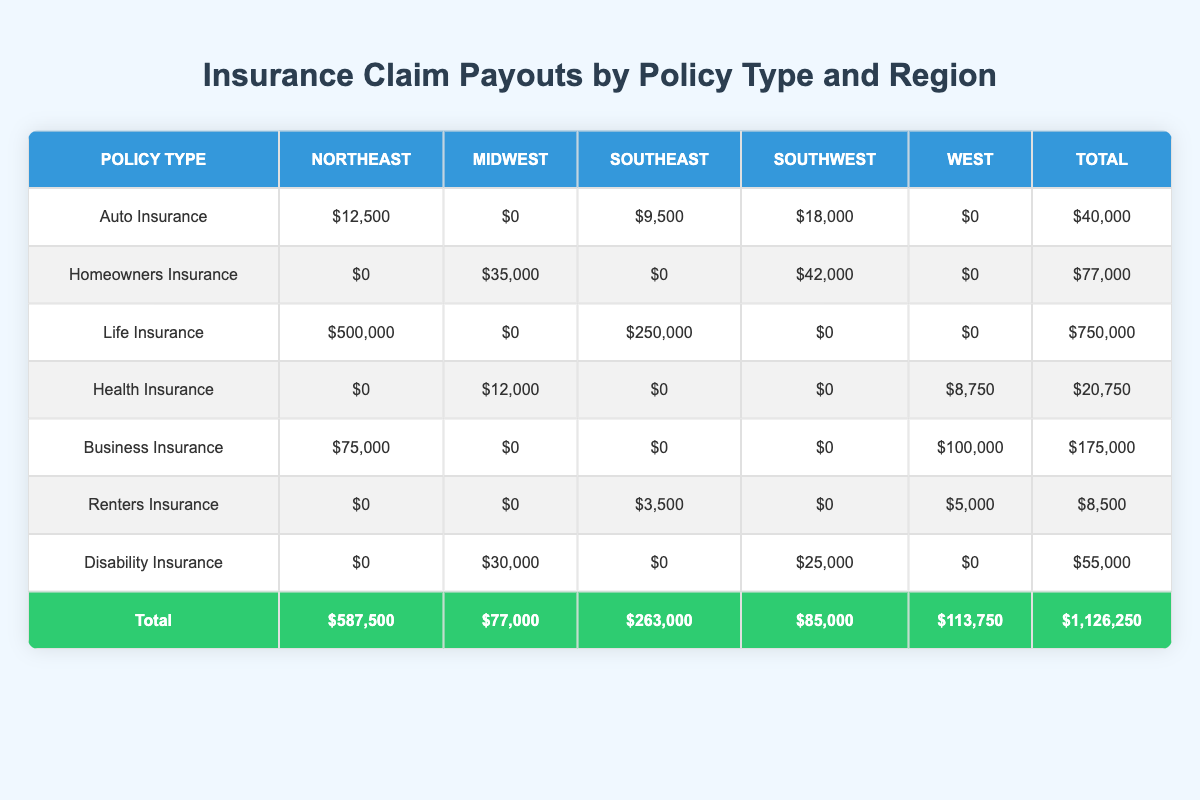What is the total claim amount for Life Insurance in the Northeast region? The table shows a claim amount of $500,000 for Life Insurance in the Northeast region. This is the only entry for Life Insurance in that region.
Answer: 500000 Which policy type received the highest total claim amount across all regions? By examining the total column, Life Insurance has the highest total claim amount of $750,000. This is greater than any other policy type totals listed.
Answer: Life Insurance What is the total claim amount for Homeowners Insurance in the Southwest region? The table indicates a claim amount of $42,000 for Homeowners Insurance under the Southwest region. This is the only entry listed for that policy type and region.
Answer: 42000 Is the total claim amount for Disability Insurance equal to the total for Renters Insurance? The total claim amount for Disability Insurance is $55,000 and for Renters Insurance, it is $8,500. Since $55,000 is not equal to $8,500, the statement is false.
Answer: No What is the difference in total payout between Auto Insurance and Business Insurance? The total payout for Auto Insurance is $40,000 and for Business Insurance, it is $175,000. The difference is calculated as $175,000 - $40,000 = $135,000.
Answer: 135000 Which region has the highest total claim payouts overall? The total column shows that the Northeast region has a total claim payout of $587,500, which is more than any other region's total (Midwest: $77,000; Southeast: $263,000; Southwest: $85,000; West: $113,750).
Answer: Northeast How much did Health Insurance claim in the West region? According to the table, the claim amount for Health Insurance in the West region is $8,750, which is correctly reflected under the respective columns.
Answer: 8750 What is the average claim amount for all types of insurance in the Midwest region? The total claim amounts in the Midwest region are: Homeowners Insurance ($35,000), Health Insurance ($12,000), and Disability Insurance ($30,000). Summing them gives $35,000 + $12,000 + $30,000 = $77,000. There are three claim amounts, so the average is $77,000 / 3 = $25,666.67.
Answer: 25666.67 